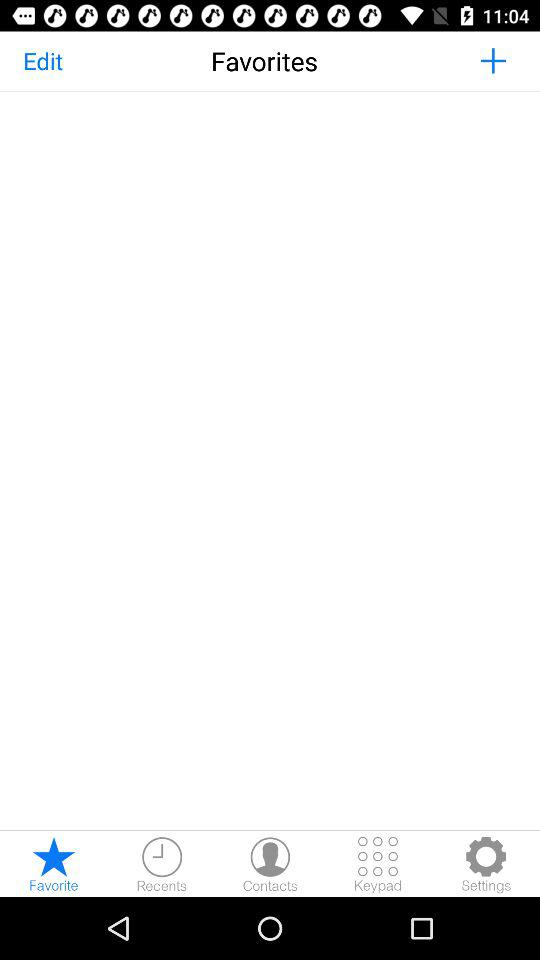Which tab am I using? You are using "Favorite" tab. 